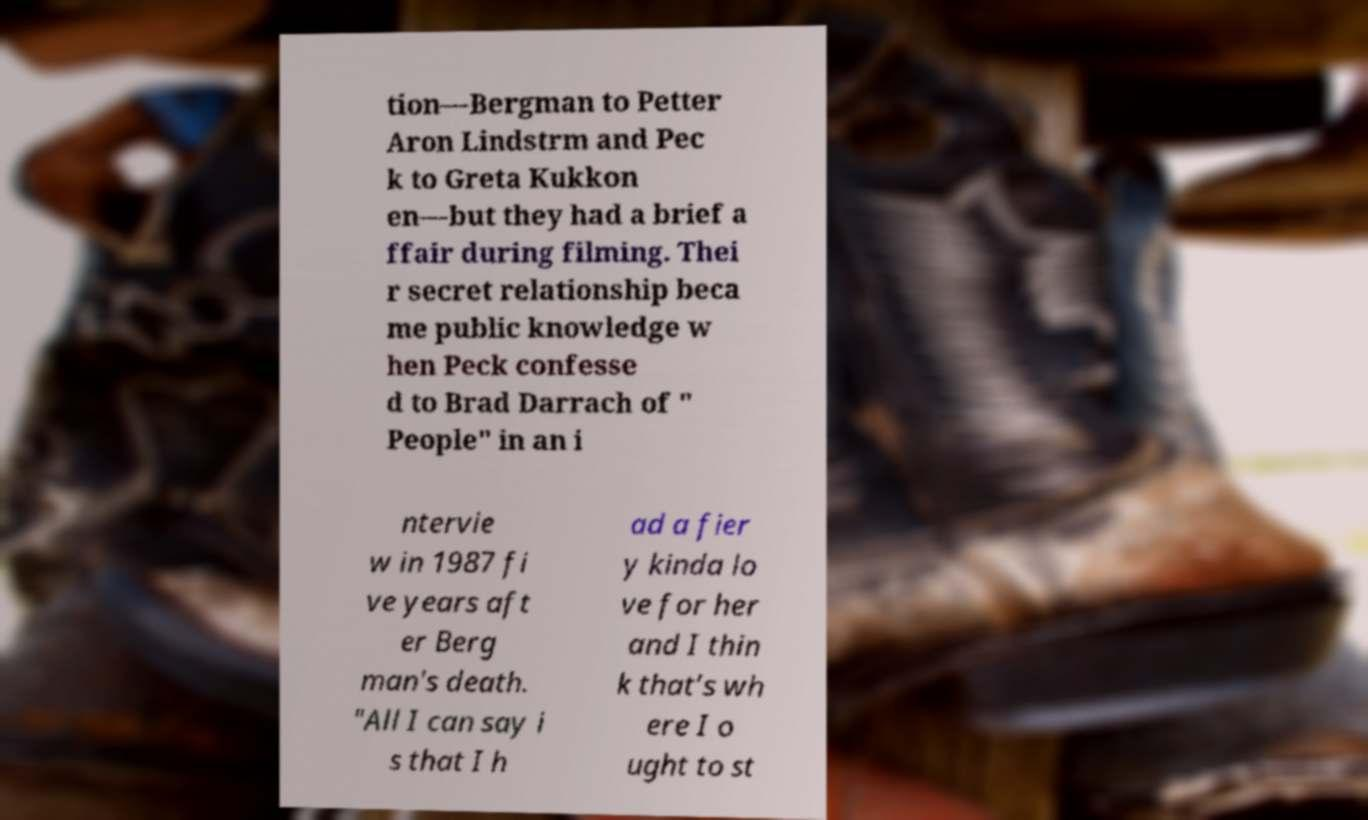Please identify and transcribe the text found in this image. tion—Bergman to Petter Aron Lindstrm and Pec k to Greta Kukkon en—but they had a brief a ffair during filming. Thei r secret relationship beca me public knowledge w hen Peck confesse d to Brad Darrach of " People" in an i ntervie w in 1987 fi ve years aft er Berg man's death. "All I can say i s that I h ad a fier y kinda lo ve for her and I thin k that’s wh ere I o ught to st 